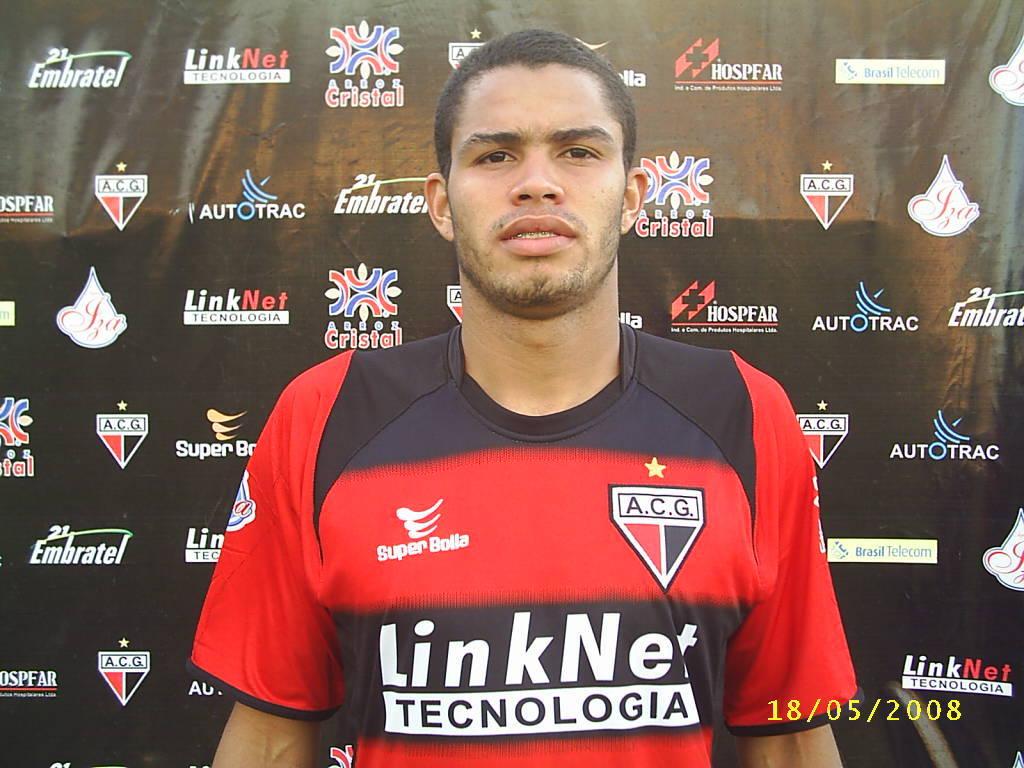Does it say acg on their shirt?
Ensure brevity in your answer.  Yes. What initials are on the shield?
Keep it short and to the point. Acg. 